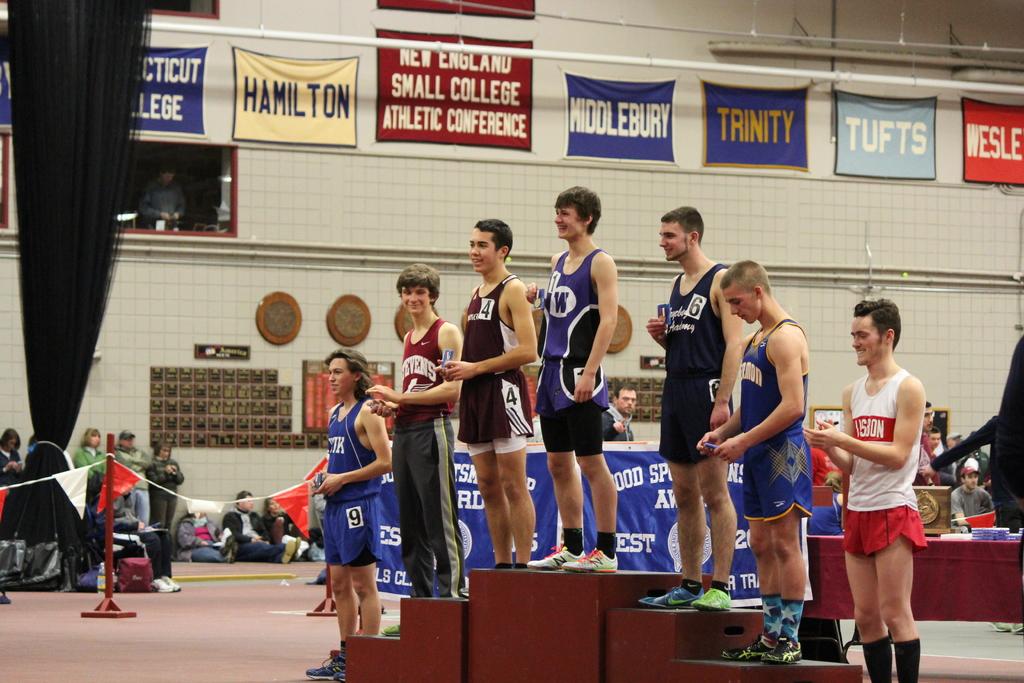What is the name on the beige banner?
Give a very brief answer. Hamilton. 